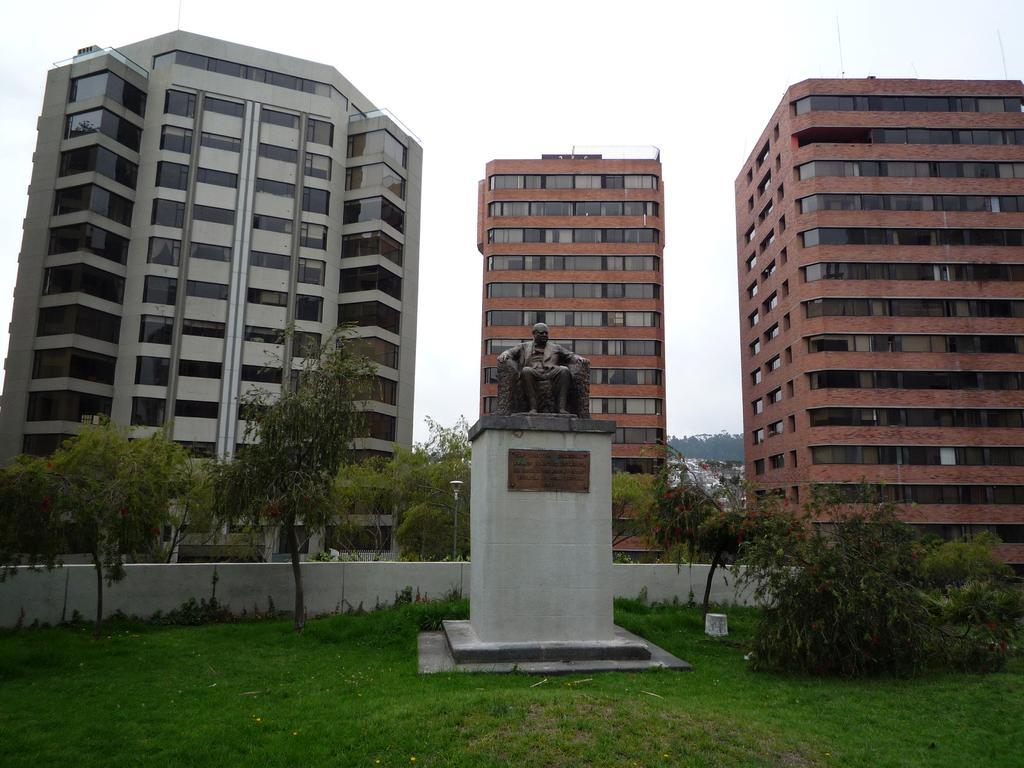Could you give a brief overview of what you see in this image? In this image we can see a statue, there are some trees, grass, buildings and the wall, in the background, we can see the sky. 